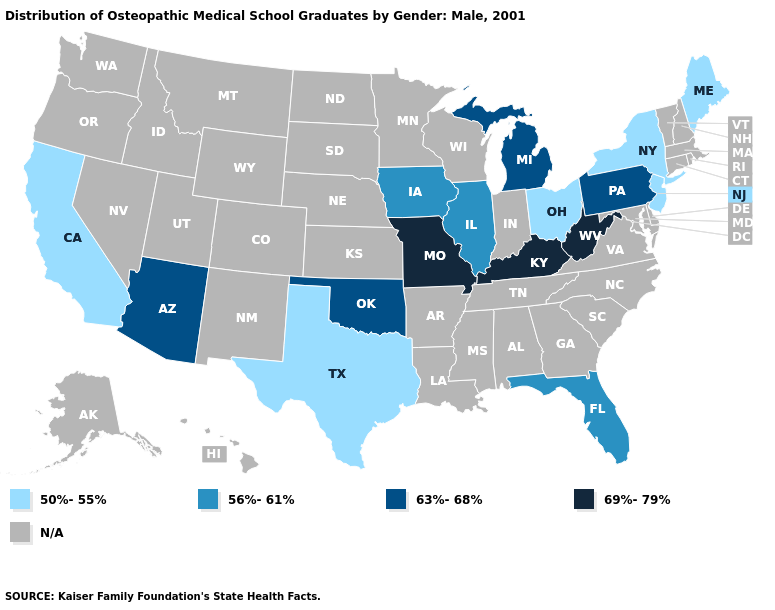What is the value of South Dakota?
Answer briefly. N/A. Does the map have missing data?
Answer briefly. Yes. What is the value of North Carolina?
Concise answer only. N/A. Name the states that have a value in the range 63%-68%?
Give a very brief answer. Arizona, Michigan, Oklahoma, Pennsylvania. What is the value of Oklahoma?
Concise answer only. 63%-68%. What is the highest value in the South ?
Answer briefly. 69%-79%. Among the states that border New Hampshire , which have the lowest value?
Give a very brief answer. Maine. What is the highest value in states that border Colorado?
Give a very brief answer. 63%-68%. Does the first symbol in the legend represent the smallest category?
Quick response, please. Yes. 